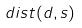Convert formula to latex. <formula><loc_0><loc_0><loc_500><loc_500>d i s t ( d , s )</formula> 